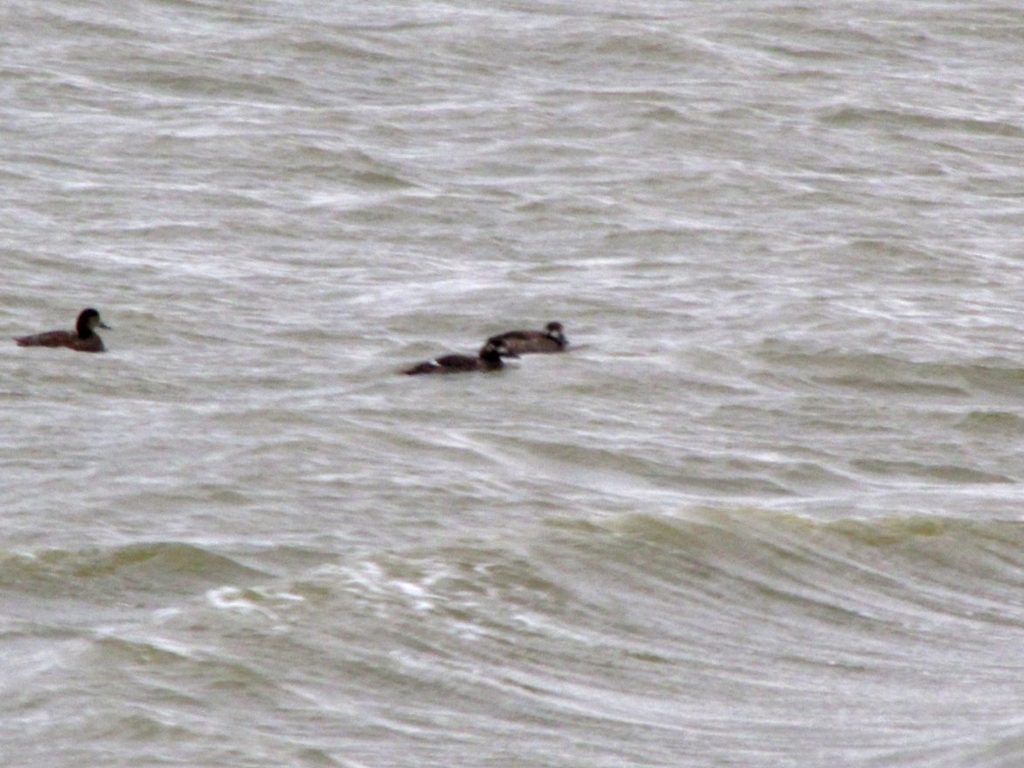What is the overall quality of this image? The overall quality of the image is below average due to its lack of sharpness, the presence of noticeable grain, and possible camera shake, which obscures finer details. However, it captures an interesting moment of wildlife, with ducks navigating through choppy water, which can be valuable from a content perspective. 